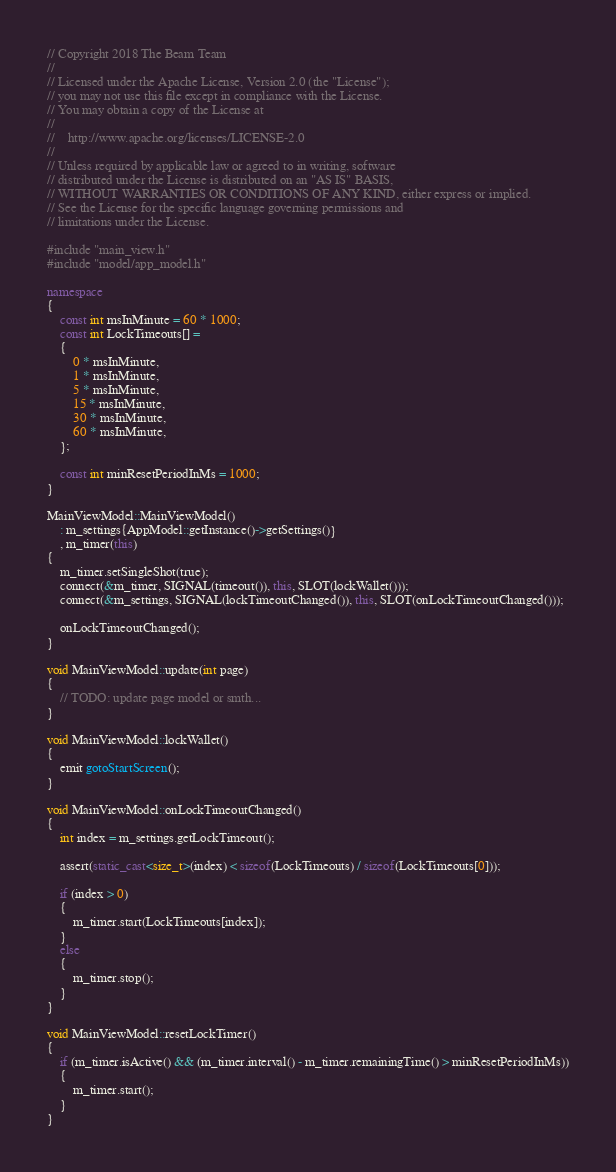Convert code to text. <code><loc_0><loc_0><loc_500><loc_500><_C++_>// Copyright 2018 The Beam Team
//
// Licensed under the Apache License, Version 2.0 (the "License");
// you may not use this file except in compliance with the License.
// You may obtain a copy of the License at
//
//    http://www.apache.org/licenses/LICENSE-2.0
//
// Unless required by applicable law or agreed to in writing, software
// distributed under the License is distributed on an "AS IS" BASIS,
// WITHOUT WARRANTIES OR CONDITIONS OF ANY KIND, either express or implied.
// See the License for the specific language governing permissions and
// limitations under the License.

#include "main_view.h"
#include "model/app_model.h"

namespace
{
    const int msInMinute = 60 * 1000;
    const int LockTimeouts[] =
    {
        0 * msInMinute,
        1 * msInMinute,
        5 * msInMinute,
        15 * msInMinute,
        30 * msInMinute,
        60 * msInMinute,
    };

    const int minResetPeriodInMs = 1000;
}

MainViewModel::MainViewModel()
    : m_settings{AppModel::getInstance()->getSettings()}
    , m_timer(this)
{
    m_timer.setSingleShot(true);
    connect(&m_timer, SIGNAL(timeout()), this, SLOT(lockWallet()));
    connect(&m_settings, SIGNAL(lockTimeoutChanged()), this, SLOT(onLockTimeoutChanged()));

    onLockTimeoutChanged();
}

void MainViewModel::update(int page)
{
	// TODO: update page model or smth...
}

void MainViewModel::lockWallet()
{
    emit gotoStartScreen();
}

void MainViewModel::onLockTimeoutChanged()
{
    int index = m_settings.getLockTimeout();

    assert(static_cast<size_t>(index) < sizeof(LockTimeouts) / sizeof(LockTimeouts[0]));

    if (index > 0)
    {
        m_timer.start(LockTimeouts[index]);
    }
    else
    {
        m_timer.stop();
    }
}

void MainViewModel::resetLockTimer()
{
    if (m_timer.isActive() && (m_timer.interval() - m_timer.remainingTime() > minResetPeriodInMs))
    {
        m_timer.start();
    }
}
</code> 